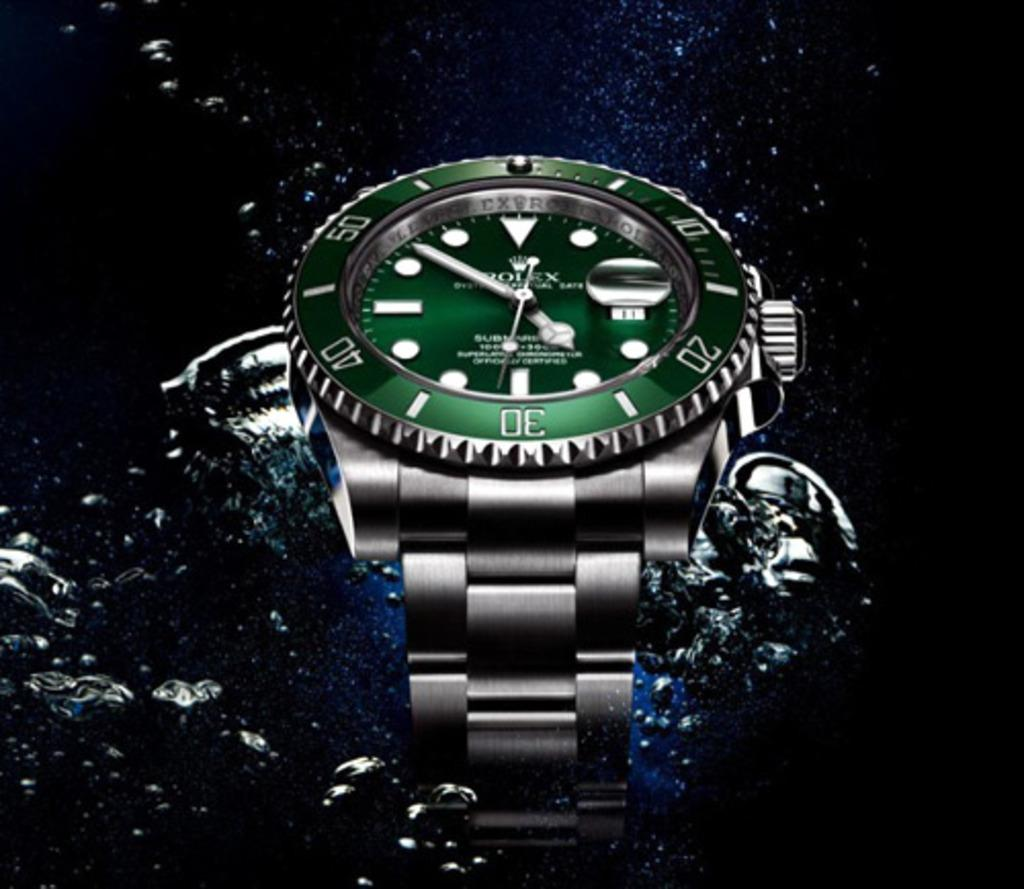<image>
Share a concise interpretation of the image provided. A Rolex watch with a green face is photographed in water. 